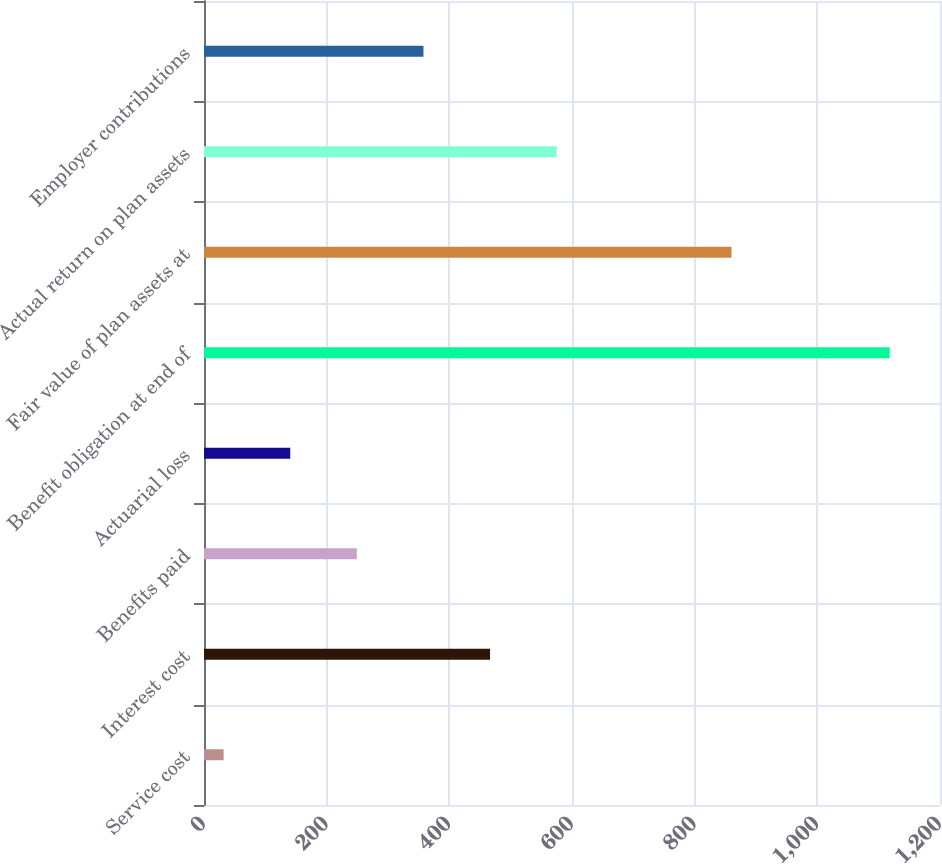Convert chart. <chart><loc_0><loc_0><loc_500><loc_500><bar_chart><fcel>Service cost<fcel>Interest cost<fcel>Benefits paid<fcel>Actuarial loss<fcel>Benefit obligation at end of<fcel>Fair value of plan assets at<fcel>Actual return on plan assets<fcel>Employer contributions<nl><fcel>32<fcel>466.4<fcel>249.2<fcel>140.6<fcel>1118<fcel>860<fcel>575<fcel>357.8<nl></chart> 